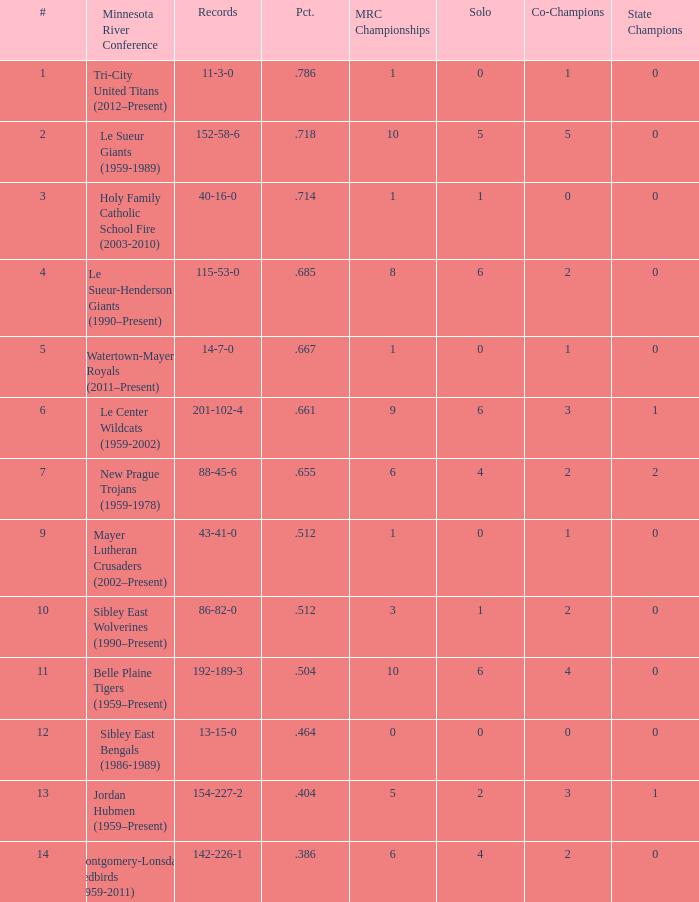What are the record(s) for the team with a victory ratio of .464? 13-15-0. 